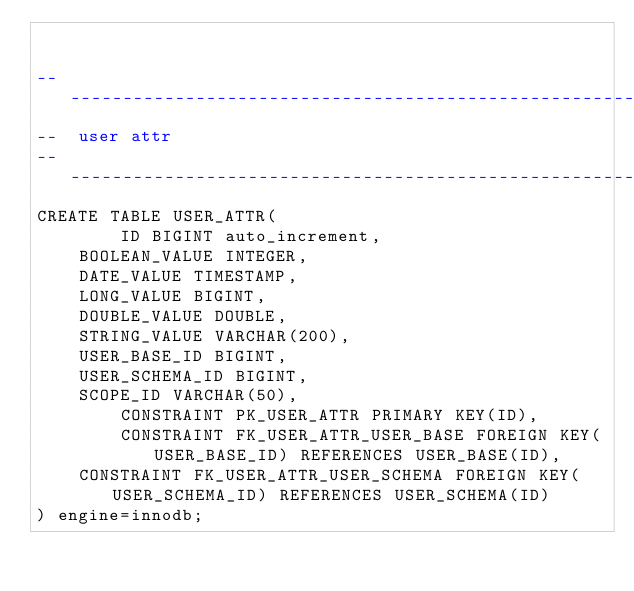<code> <loc_0><loc_0><loc_500><loc_500><_SQL_>

-------------------------------------------------------------------------------
--  user attr
-------------------------------------------------------------------------------
CREATE TABLE USER_ATTR(
        ID BIGINT auto_increment,
	BOOLEAN_VALUE INTEGER,
	DATE_VALUE TIMESTAMP,
	LONG_VALUE BIGINT,
	DOUBLE_VALUE DOUBLE,
	STRING_VALUE VARCHAR(200),
	USER_BASE_ID BIGINT,
	USER_SCHEMA_ID BIGINT,
	SCOPE_ID VARCHAR(50),
        CONSTRAINT PK_USER_ATTR PRIMARY KEY(ID),
        CONSTRAINT FK_USER_ATTR_USER_BASE FOREIGN KEY(USER_BASE_ID) REFERENCES USER_BASE(ID),
	CONSTRAINT FK_USER_ATTR_USER_SCHEMA FOREIGN KEY(USER_SCHEMA_ID) REFERENCES USER_SCHEMA(ID)
) engine=innodb;
</code> 